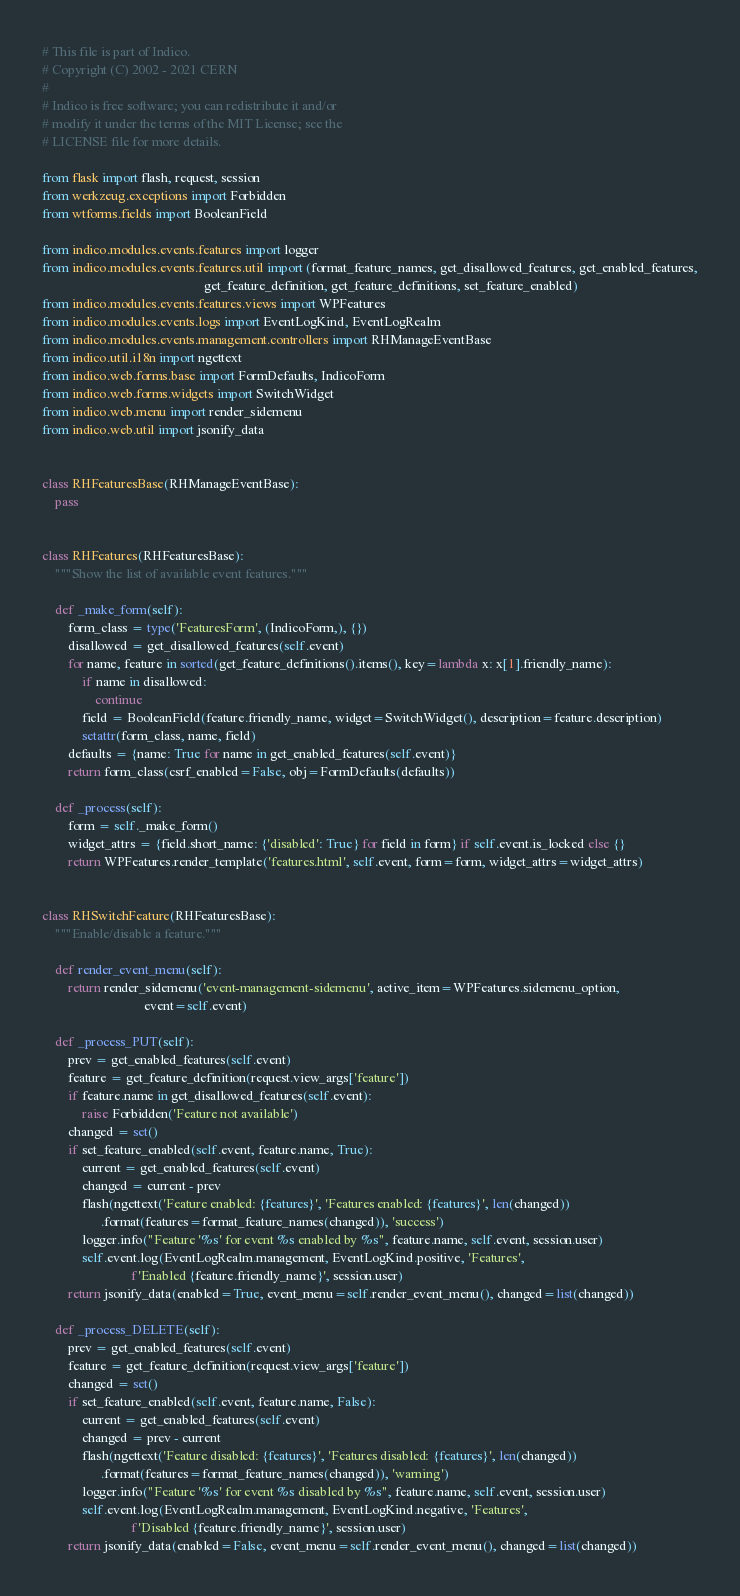<code> <loc_0><loc_0><loc_500><loc_500><_Python_># This file is part of Indico.
# Copyright (C) 2002 - 2021 CERN
#
# Indico is free software; you can redistribute it and/or
# modify it under the terms of the MIT License; see the
# LICENSE file for more details.

from flask import flash, request, session
from werkzeug.exceptions import Forbidden
from wtforms.fields import BooleanField

from indico.modules.events.features import logger
from indico.modules.events.features.util import (format_feature_names, get_disallowed_features, get_enabled_features,
                                                 get_feature_definition, get_feature_definitions, set_feature_enabled)
from indico.modules.events.features.views import WPFeatures
from indico.modules.events.logs import EventLogKind, EventLogRealm
from indico.modules.events.management.controllers import RHManageEventBase
from indico.util.i18n import ngettext
from indico.web.forms.base import FormDefaults, IndicoForm
from indico.web.forms.widgets import SwitchWidget
from indico.web.menu import render_sidemenu
from indico.web.util import jsonify_data


class RHFeaturesBase(RHManageEventBase):
    pass


class RHFeatures(RHFeaturesBase):
    """Show the list of available event features."""

    def _make_form(self):
        form_class = type('FeaturesForm', (IndicoForm,), {})
        disallowed = get_disallowed_features(self.event)
        for name, feature in sorted(get_feature_definitions().items(), key=lambda x: x[1].friendly_name):
            if name in disallowed:
                continue
            field = BooleanField(feature.friendly_name, widget=SwitchWidget(), description=feature.description)
            setattr(form_class, name, field)
        defaults = {name: True for name in get_enabled_features(self.event)}
        return form_class(csrf_enabled=False, obj=FormDefaults(defaults))

    def _process(self):
        form = self._make_form()
        widget_attrs = {field.short_name: {'disabled': True} for field in form} if self.event.is_locked else {}
        return WPFeatures.render_template('features.html', self.event, form=form, widget_attrs=widget_attrs)


class RHSwitchFeature(RHFeaturesBase):
    """Enable/disable a feature."""

    def render_event_menu(self):
        return render_sidemenu('event-management-sidemenu', active_item=WPFeatures.sidemenu_option,
                               event=self.event)

    def _process_PUT(self):
        prev = get_enabled_features(self.event)
        feature = get_feature_definition(request.view_args['feature'])
        if feature.name in get_disallowed_features(self.event):
            raise Forbidden('Feature not available')
        changed = set()
        if set_feature_enabled(self.event, feature.name, True):
            current = get_enabled_features(self.event)
            changed = current - prev
            flash(ngettext('Feature enabled: {features}', 'Features enabled: {features}', len(changed))
                  .format(features=format_feature_names(changed)), 'success')
            logger.info("Feature '%s' for event %s enabled by %s", feature.name, self.event, session.user)
            self.event.log(EventLogRealm.management, EventLogKind.positive, 'Features',
                           f'Enabled {feature.friendly_name}', session.user)
        return jsonify_data(enabled=True, event_menu=self.render_event_menu(), changed=list(changed))

    def _process_DELETE(self):
        prev = get_enabled_features(self.event)
        feature = get_feature_definition(request.view_args['feature'])
        changed = set()
        if set_feature_enabled(self.event, feature.name, False):
            current = get_enabled_features(self.event)
            changed = prev - current
            flash(ngettext('Feature disabled: {features}', 'Features disabled: {features}', len(changed))
                  .format(features=format_feature_names(changed)), 'warning')
            logger.info("Feature '%s' for event %s disabled by %s", feature.name, self.event, session.user)
            self.event.log(EventLogRealm.management, EventLogKind.negative, 'Features',
                           f'Disabled {feature.friendly_name}', session.user)
        return jsonify_data(enabled=False, event_menu=self.render_event_menu(), changed=list(changed))
</code> 